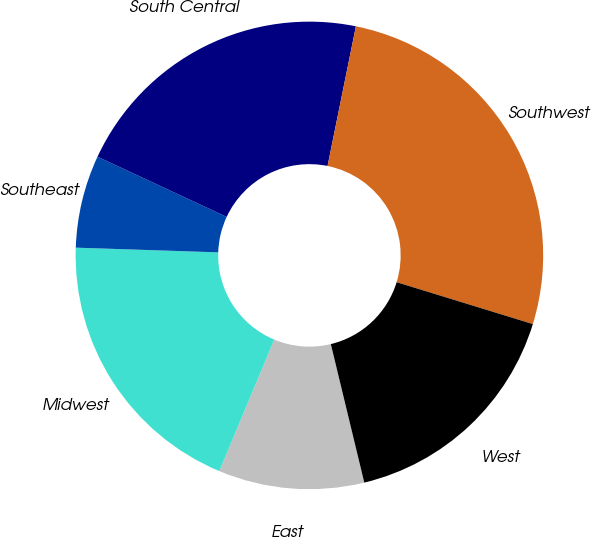<chart> <loc_0><loc_0><loc_500><loc_500><pie_chart><fcel>East<fcel>Midwest<fcel>Southeast<fcel>South Central<fcel>Southwest<fcel>West<nl><fcel>10.07%<fcel>19.23%<fcel>6.41%<fcel>21.25%<fcel>26.56%<fcel>16.48%<nl></chart> 